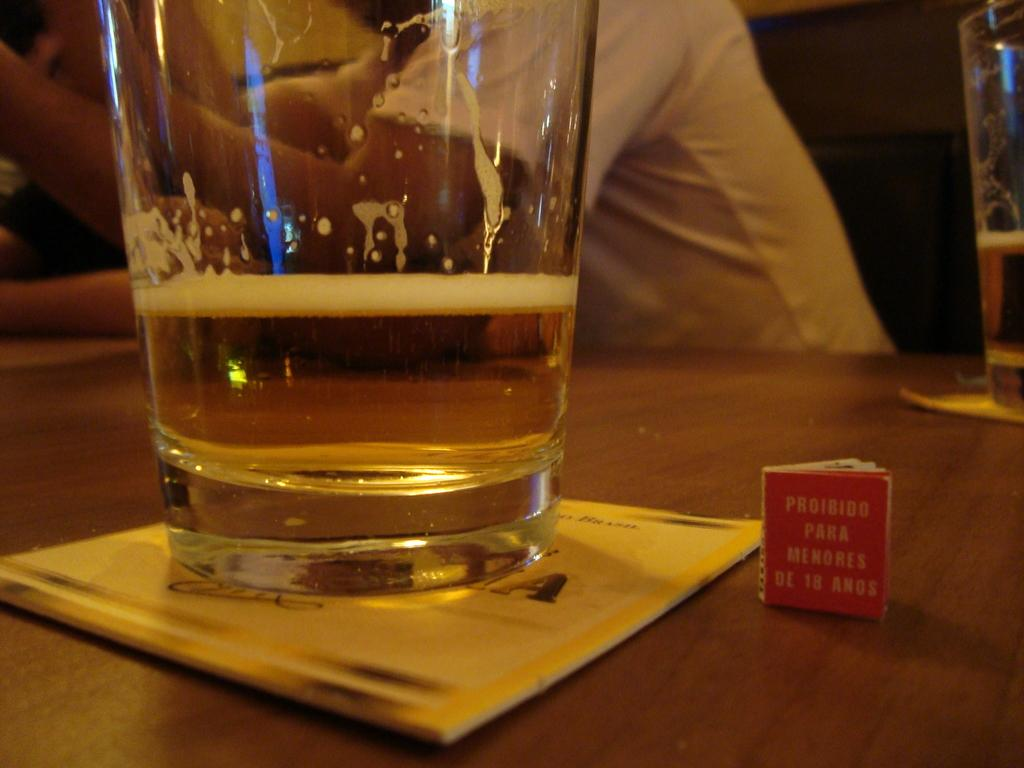<image>
Share a concise interpretation of the image provided. A small red tag with the last words reading de 18 anos. 